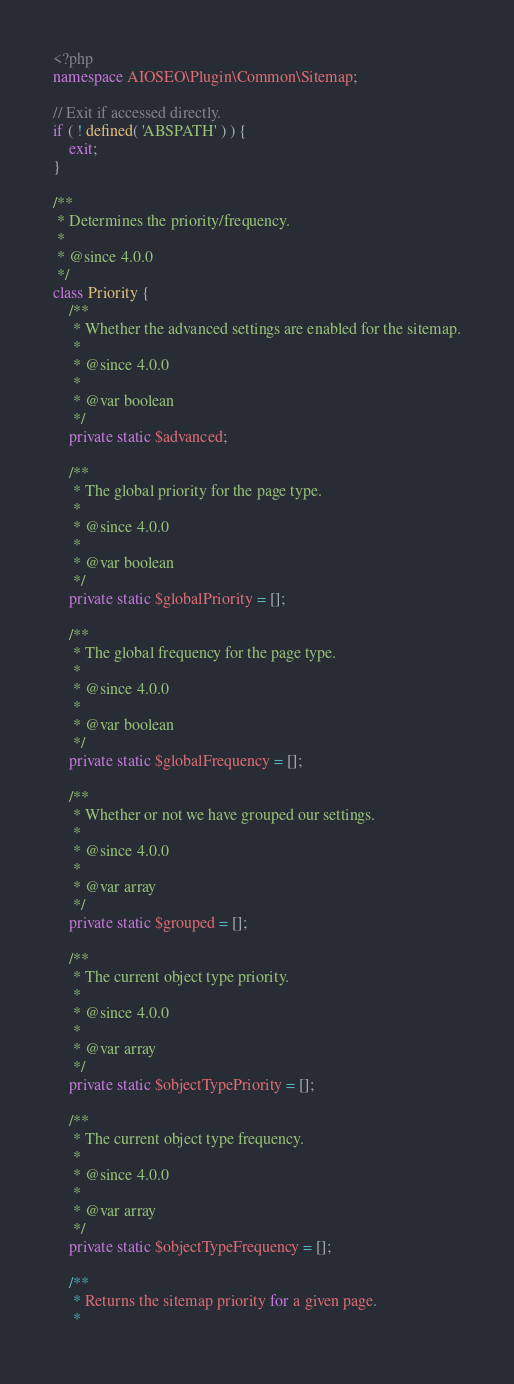Convert code to text. <code><loc_0><loc_0><loc_500><loc_500><_PHP_><?php
namespace AIOSEO\Plugin\Common\Sitemap;

// Exit if accessed directly.
if ( ! defined( 'ABSPATH' ) ) {
	exit;
}

/**
 * Determines the priority/frequency.
 *
 * @since 4.0.0
 */
class Priority {
	/**
	 * Whether the advanced settings are enabled for the sitemap.
	 *
	 * @since 4.0.0
	 *
	 * @var boolean
	 */
	private static $advanced;

	/**
	 * The global priority for the page type.
	 *
	 * @since 4.0.0
	 *
	 * @var boolean
	 */
	private static $globalPriority = [];

	/**
	 * The global frequency for the page type.
	 *
	 * @since 4.0.0
	 *
	 * @var boolean
	 */
	private static $globalFrequency = [];

	/**
	 * Whether or not we have grouped our settings.
	 *
	 * @since 4.0.0
	 *
	 * @var array
	 */
	private static $grouped = [];

	/**
	 * The current object type priority.
	 *
	 * @since 4.0.0
	 *
	 * @var array
	 */
	private static $objectTypePriority = [];

	/**
	 * The current object type frequency.
	 *
	 * @since 4.0.0
	 *
	 * @var array
	 */
	private static $objectTypeFrequency = [];

	/**
	 * Returns the sitemap priority for a given page.
	 *</code> 